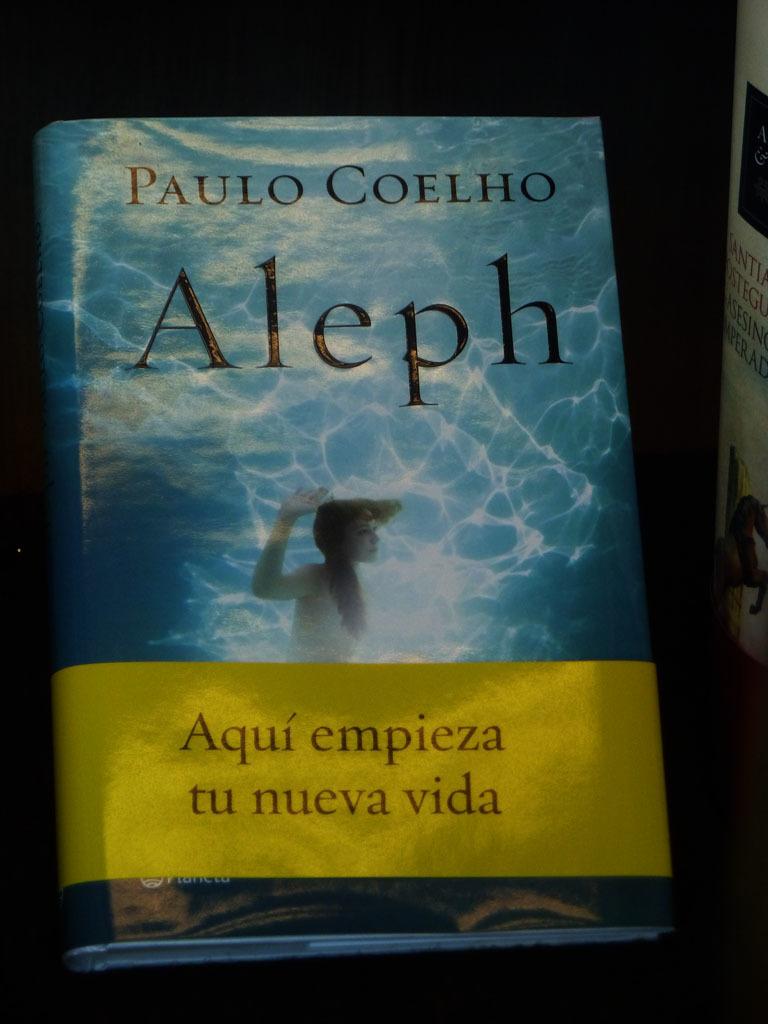Is this by paulo coelho?
Offer a very short reply. Yes. What is the title of the book?
Offer a terse response. Aleph. 